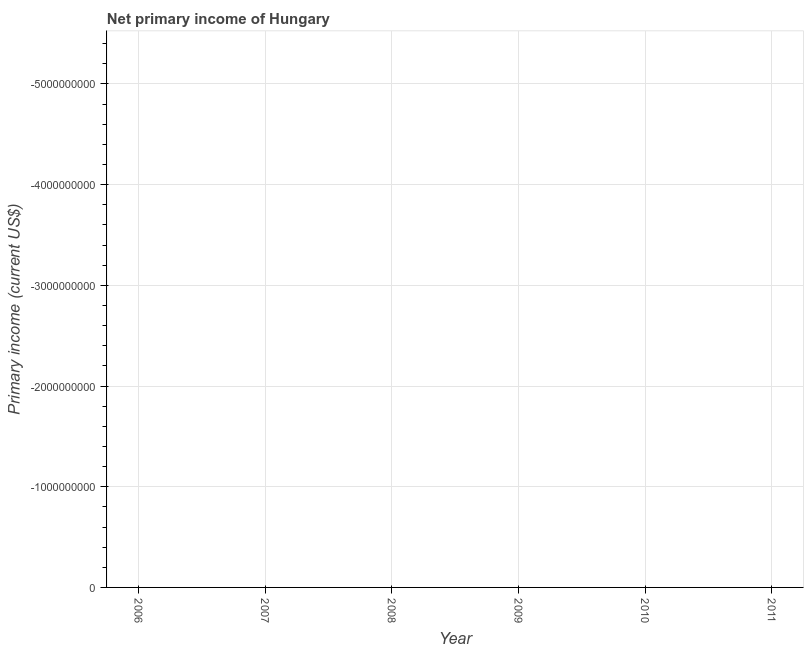What is the average amount of primary income per year?
Your answer should be very brief. 0. What is the median amount of primary income?
Ensure brevity in your answer.  0. In how many years, is the amount of primary income greater than -2400000000 US$?
Ensure brevity in your answer.  0. Does the amount of primary income monotonically increase over the years?
Your response must be concise. No. How many years are there in the graph?
Your answer should be very brief. 6. What is the difference between two consecutive major ticks on the Y-axis?
Your answer should be very brief. 1.00e+09. Does the graph contain any zero values?
Offer a terse response. Yes. Does the graph contain grids?
Your answer should be very brief. Yes. What is the title of the graph?
Your response must be concise. Net primary income of Hungary. What is the label or title of the X-axis?
Offer a very short reply. Year. What is the label or title of the Y-axis?
Provide a succinct answer. Primary income (current US$). What is the Primary income (current US$) in 2006?
Offer a very short reply. 0. What is the Primary income (current US$) in 2008?
Your answer should be very brief. 0. What is the Primary income (current US$) in 2010?
Your answer should be very brief. 0. What is the Primary income (current US$) in 2011?
Your answer should be very brief. 0. 